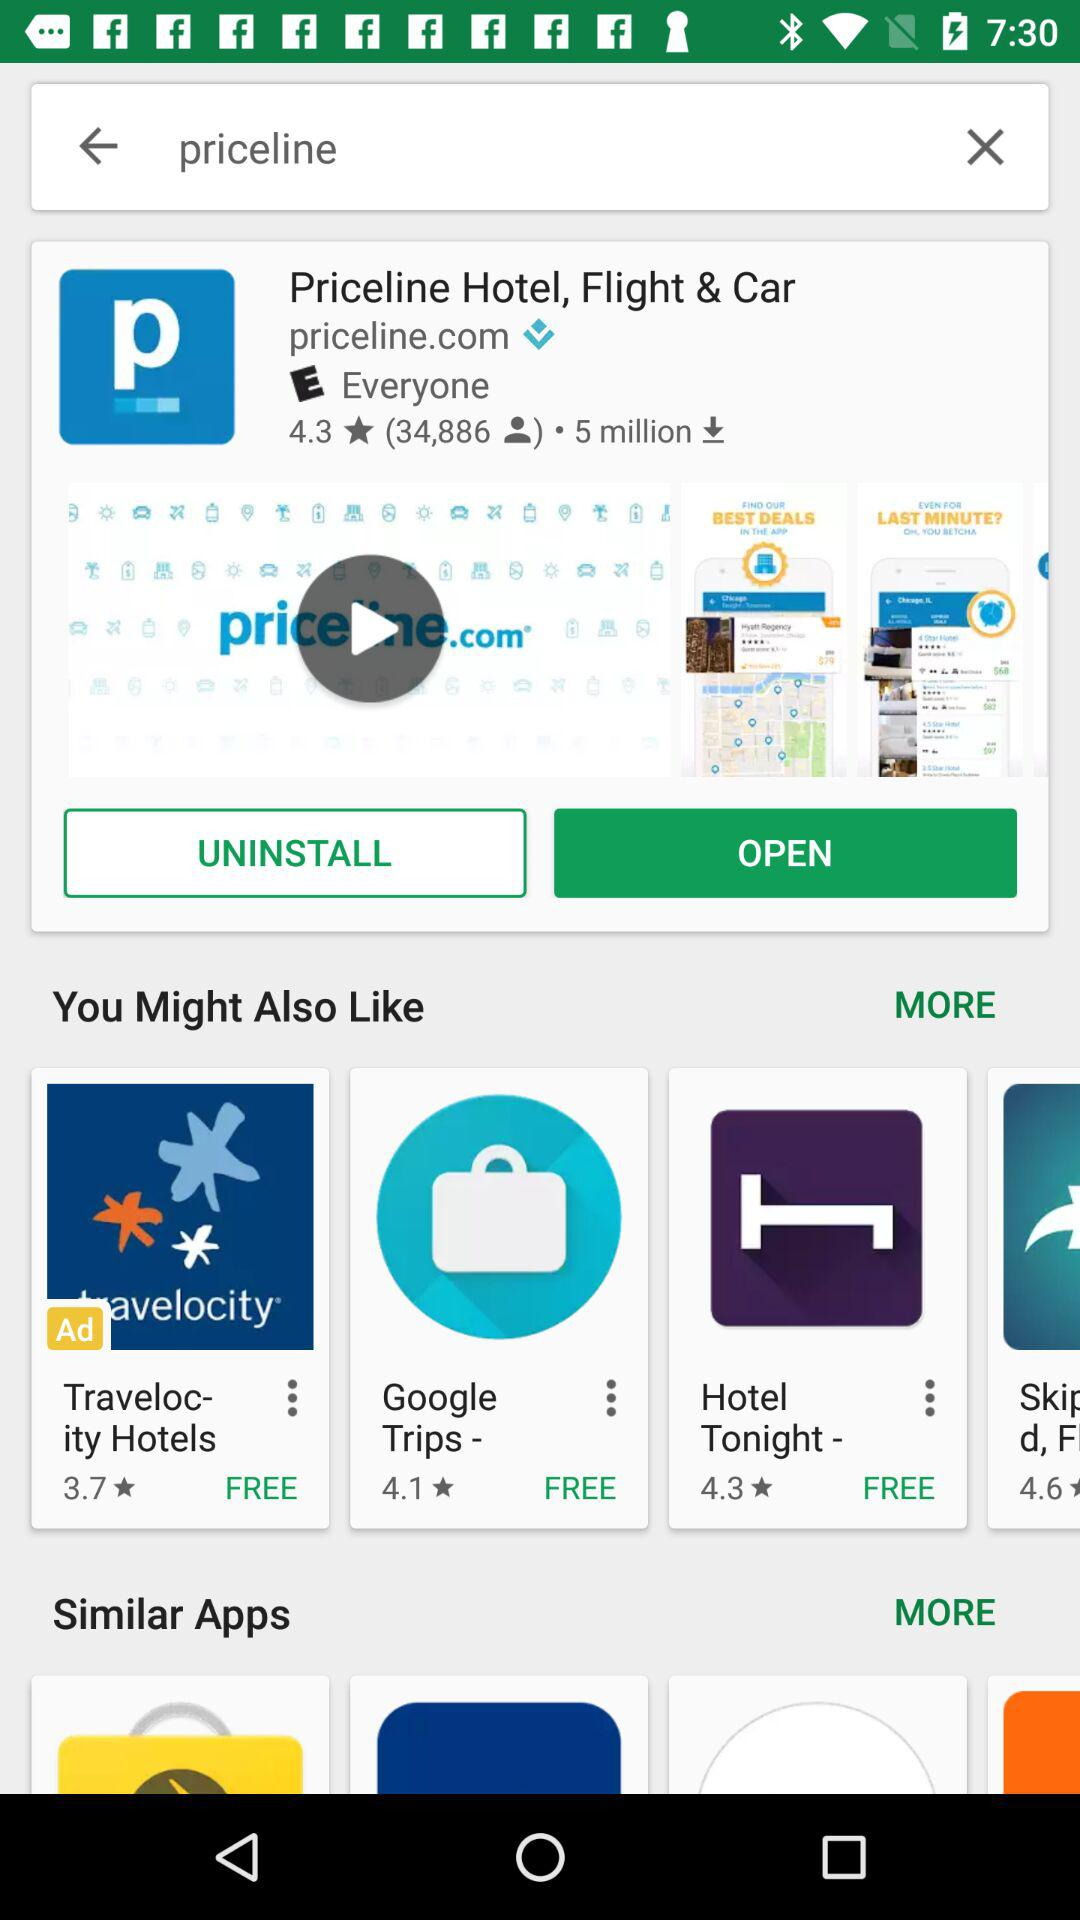What is the star rating of the "Priceline Hotel, Flight & Car" application? The star rating of the "Priceline Hotel, Flight & Car" application is 4.3. 